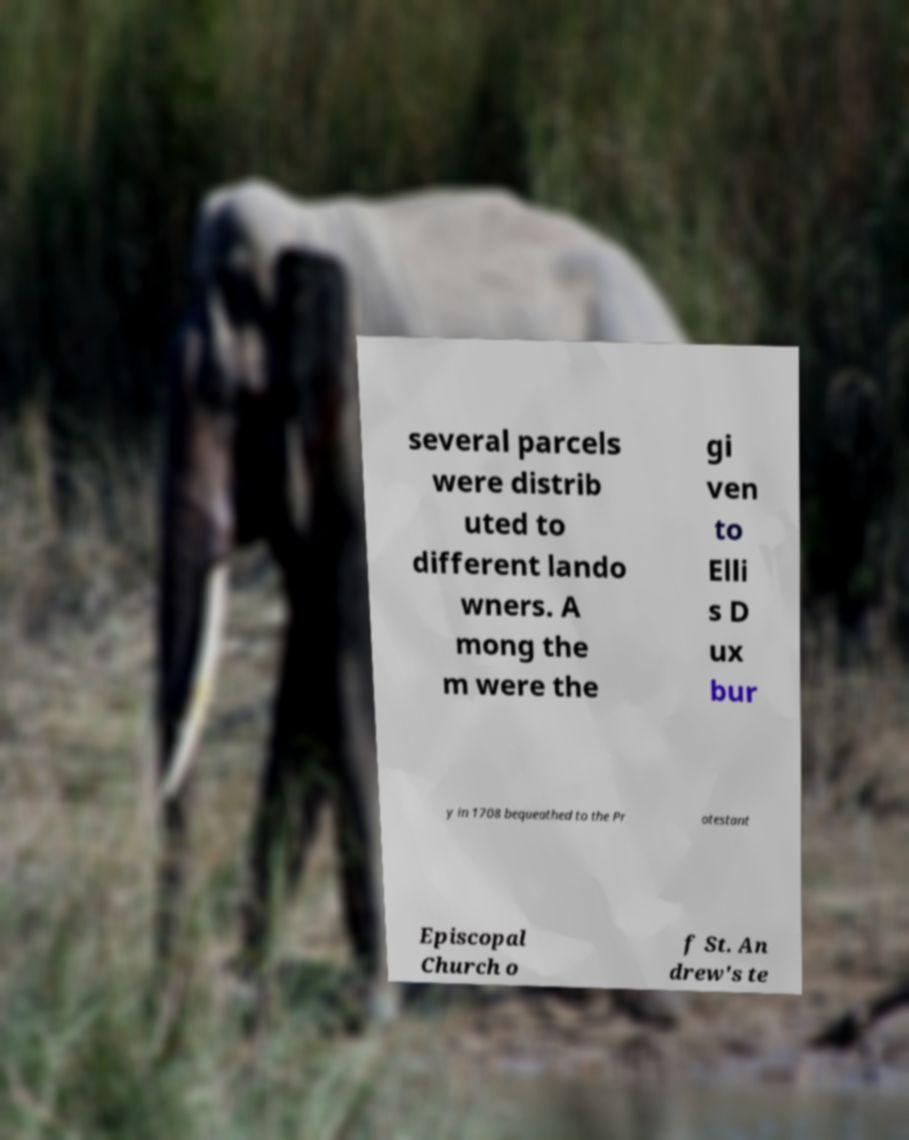Can you read and provide the text displayed in the image?This photo seems to have some interesting text. Can you extract and type it out for me? several parcels were distrib uted to different lando wners. A mong the m were the gi ven to Elli s D ux bur y in 1708 bequeathed to the Pr otestant Episcopal Church o f St. An drew's te 